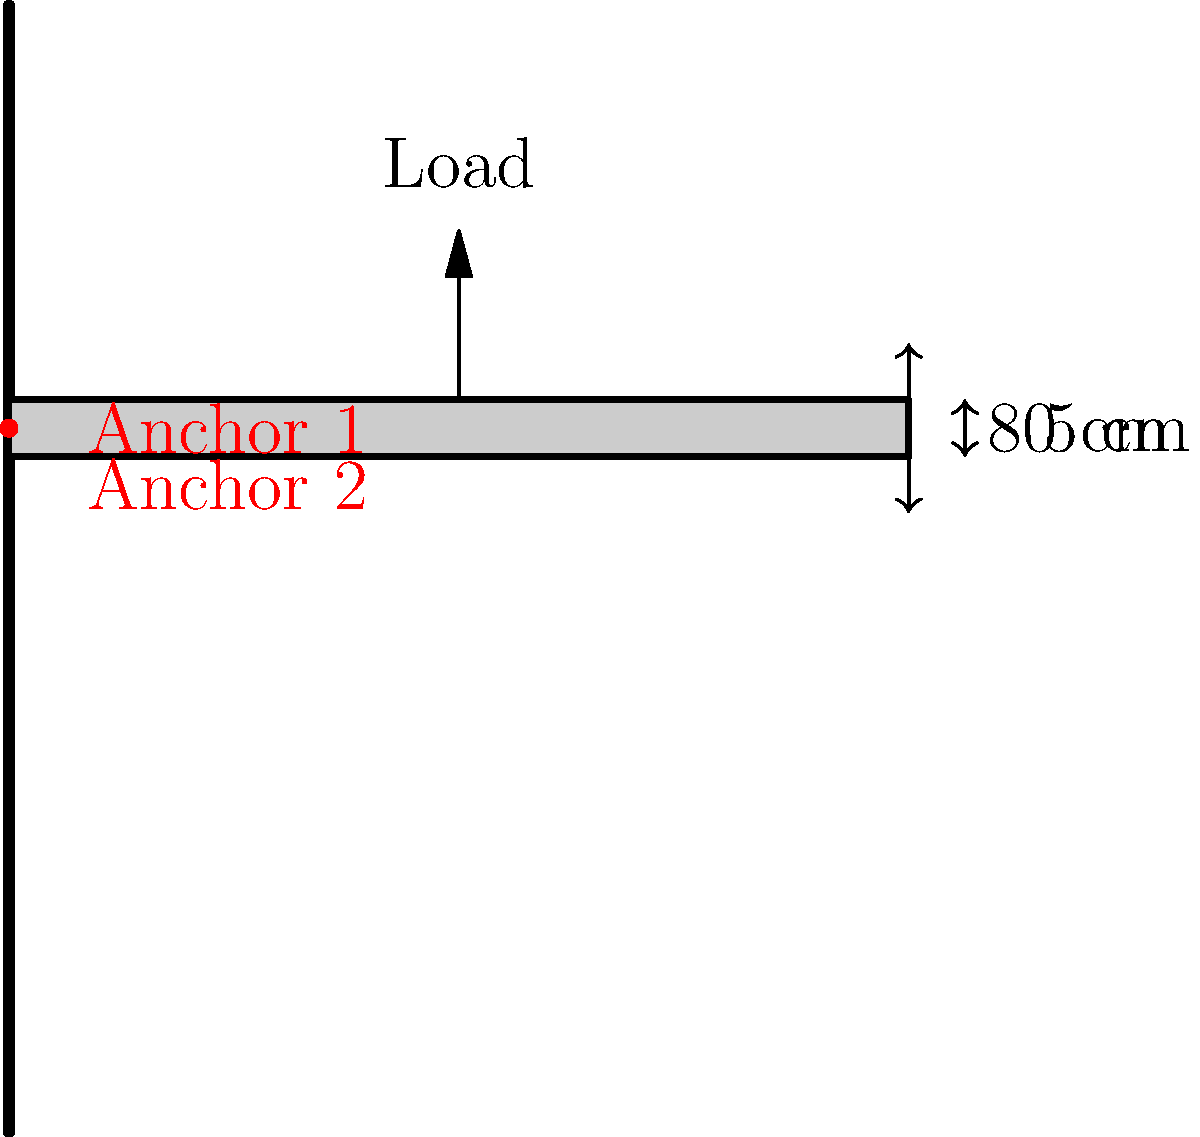You're designing a DIY floating desk for a client's home office. The desk will be 80 cm deep and 5 cm thick, mounted on a drywall using two heavy-duty wall anchors. Each anchor is rated to support 50 kg when properly installed. Assuming an even weight distribution and a safety factor of 1.5, what is the maximum load the desk can safely support? To calculate the maximum safe load for the DIY floating desk, we'll follow these steps:

1. Determine the total support capacity of the anchors:
   - Each anchor supports 50 kg
   - Total support = $2 \times 50$ kg = 100 kg

2. Apply the safety factor:
   - Safety factor = 1.5
   - Safe load = Total support ÷ Safety factor
   - Safe load = $100 \text{ kg} \div 1.5$ = 66.67 kg

3. Convert the result to newtons:
   - Force (N) = Mass (kg) × Acceleration due to gravity (m/s²)
   - Acceleration due to gravity ≈ 9.81 m/s²
   - Maximum safe load = $66.67 \text{ kg} \times 9.81 \text{ m/s²}$ = 654.03 N

4. Round down to the nearest whole number for added safety:
   - Maximum safe load = 654 N

Therefore, the maximum load the desk can safely support is 654 N.
Answer: 654 N 